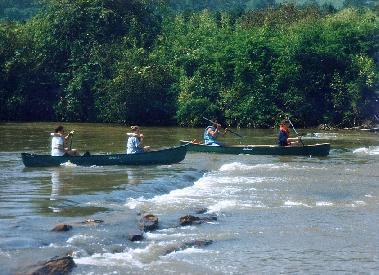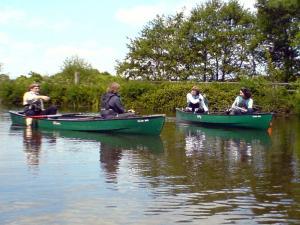The first image is the image on the left, the second image is the image on the right. For the images displayed, is the sentence "There are canoes sitting on the beach" factually correct? Answer yes or no. No. The first image is the image on the left, the second image is the image on the right. Analyze the images presented: Is the assertion "At least one image shows watercraft that is pulled up to the edge of the water." valid? Answer yes or no. No. 